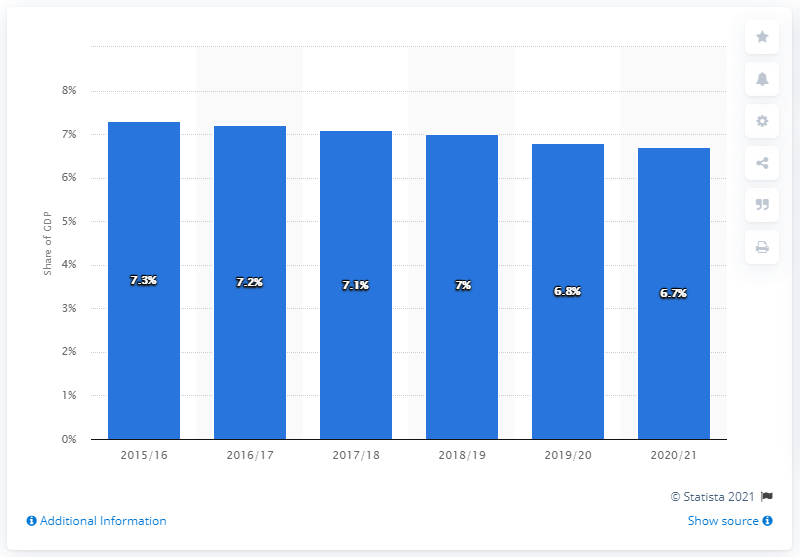Specify some key components in this picture. Public spending on health was forecasted to be a percentage of GDP in the UK during the 2015/16 fiscal year. The forecast for a reduction in public spending on health as a percentage of GDP by the year 2020/21 is expected to be approximately 6.7%. 